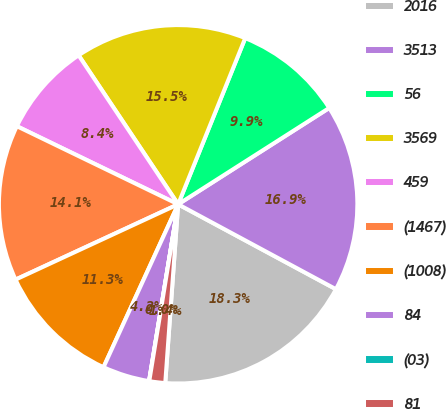Convert chart. <chart><loc_0><loc_0><loc_500><loc_500><pie_chart><fcel>2016<fcel>3513<fcel>56<fcel>3569<fcel>459<fcel>(1467)<fcel>(1008)<fcel>84<fcel>(03)<fcel>81<nl><fcel>18.29%<fcel>16.89%<fcel>9.86%<fcel>15.48%<fcel>8.45%<fcel>14.08%<fcel>11.26%<fcel>4.24%<fcel>0.02%<fcel>1.43%<nl></chart> 